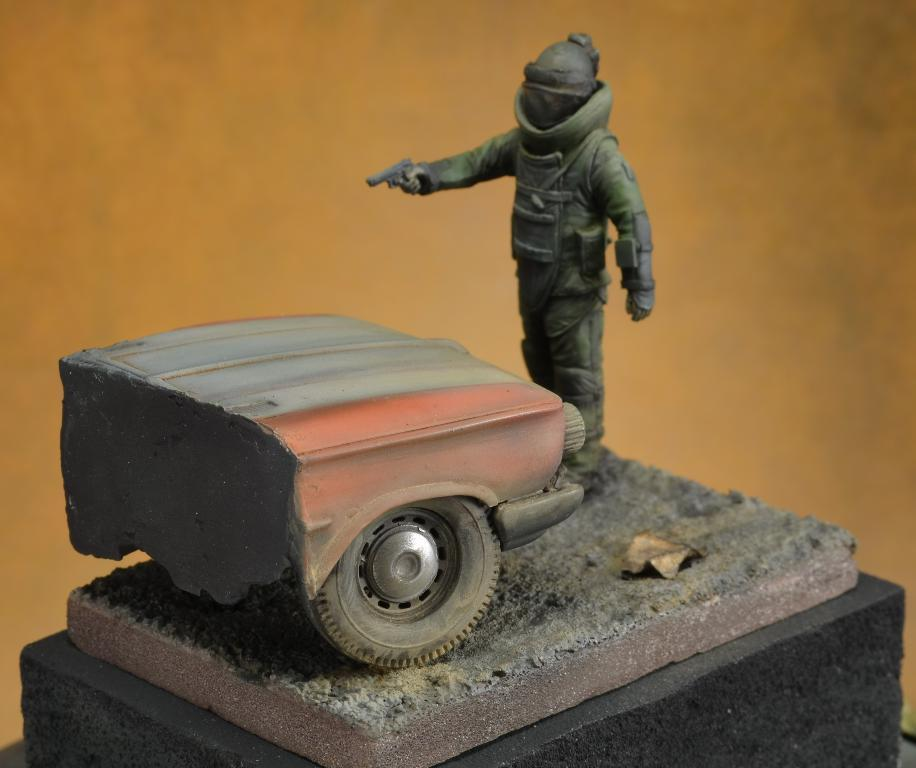What is the main subject in the center of the image? There is a statue in the center of the image. Is the statue elevated in any way? Yes, the statue is on a pedestal. What can be seen in the background of the image? There is a wall in the background of the image. Are there any lizards crawling on the statue in the image? There is no indication of lizards or any other animals present on the statue in the image. 